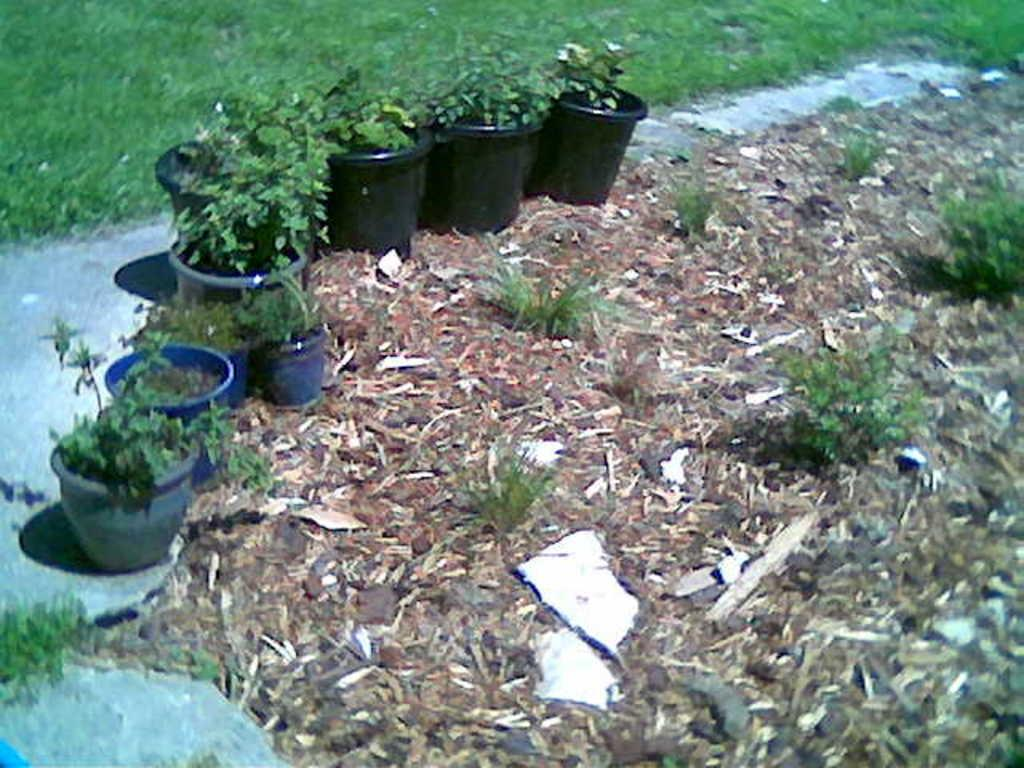What objects are placed on the ground in the image? There are flower pots on the ground in the image. What is the color scheme of the image? The image is in black and blue color. What type of natural elements can be seen in the image? Dried sticks and grass are visible in the image. What type of vegetation is present in the image? There are plants in the image. What type of insurance policy is being discussed in the image? There is no discussion of insurance policies in the image; it features flower pots, dried sticks, grass, and plants. What type of silk material is draped over the plants in the image? There is no silk material present in the image; it only features flower pots, dried sticks, grass, and plants. 